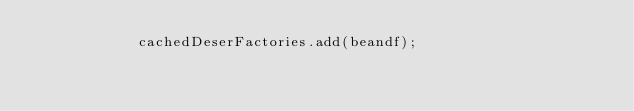<code> <loc_0><loc_0><loc_500><loc_500><_Java_>            cachedDeserFactories.add(beandf);
</code> 